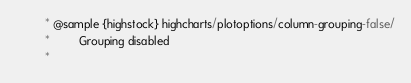<code> <loc_0><loc_0><loc_500><loc_500><_JavaScript_>         * @sample {highstock} highcharts/plotoptions/column-grouping-false/
         *         Grouping disabled
         *</code> 